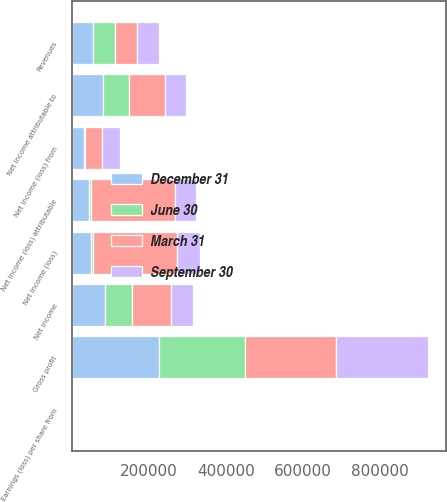Convert chart. <chart><loc_0><loc_0><loc_500><loc_500><stacked_bar_chart><ecel><fcel>Revenues<fcel>Gross profit<fcel>Net income (loss)<fcel>Net income (loss) attributable<fcel>Net income (loss) from<fcel>Earnings (loss) per share from<fcel>Net income<fcel>Net income attributable to<nl><fcel>September 30<fcel>56296.5<fcel>237906<fcel>58185<fcel>53484<fcel>47689<fcel>0.22<fcel>58648<fcel>54408<nl><fcel>December 31<fcel>56296.5<fcel>227505<fcel>49565<fcel>46109<fcel>32007<fcel>0.15<fcel>85444<fcel>81082<nl><fcel>March 31<fcel>56296.5<fcel>235215<fcel>218956<fcel>216388<fcel>43176<fcel>0.23<fcel>100015<fcel>94648<nl><fcel>June 30<fcel>56296.5<fcel>223039<fcel>4882<fcel>5074<fcel>2586<fcel>0.02<fcel>70975<fcel>66576<nl></chart> 